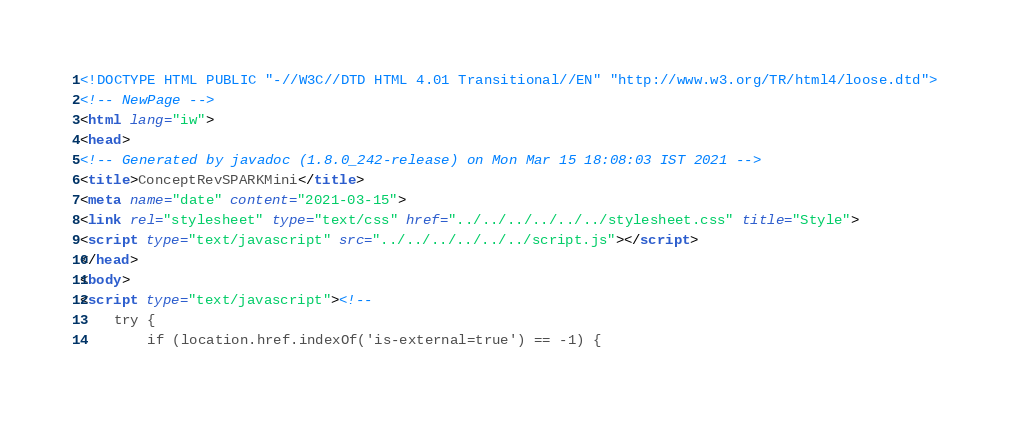Convert code to text. <code><loc_0><loc_0><loc_500><loc_500><_HTML_><!DOCTYPE HTML PUBLIC "-//W3C//DTD HTML 4.01 Transitional//EN" "http://www.w3.org/TR/html4/loose.dtd">
<!-- NewPage -->
<html lang="iw">
<head>
<!-- Generated by javadoc (1.8.0_242-release) on Mon Mar 15 18:08:03 IST 2021 -->
<title>ConceptRevSPARKMini</title>
<meta name="date" content="2021-03-15">
<link rel="stylesheet" type="text/css" href="../../../../../../stylesheet.css" title="Style">
<script type="text/javascript" src="../../../../../../script.js"></script>
</head>
<body>
<script type="text/javascript"><!--
    try {
        if (location.href.indexOf('is-external=true') == -1) {</code> 